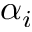<formula> <loc_0><loc_0><loc_500><loc_500>\alpha _ { i }</formula> 